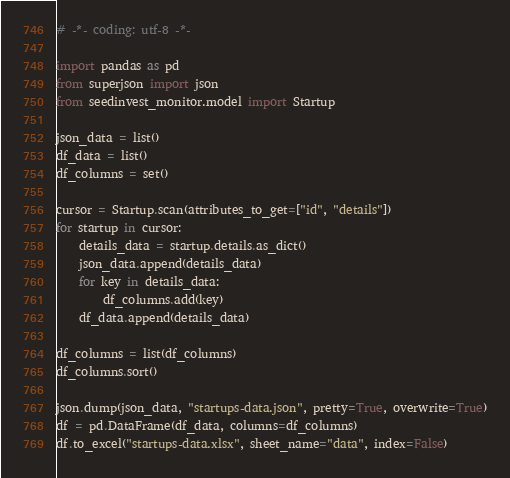Convert code to text. <code><loc_0><loc_0><loc_500><loc_500><_Python_># -*- coding: utf-8 -*-

import pandas as pd
from superjson import json
from seedinvest_monitor.model import Startup

json_data = list()
df_data = list()
df_columns = set()

cursor = Startup.scan(attributes_to_get=["id", "details"])
for startup in cursor:
    details_data = startup.details.as_dict()
    json_data.append(details_data)
    for key in details_data:
        df_columns.add(key)
    df_data.append(details_data)

df_columns = list(df_columns)
df_columns.sort()

json.dump(json_data, "startups-data.json", pretty=True, overwrite=True)
df = pd.DataFrame(df_data, columns=df_columns)
df.to_excel("startups-data.xlsx", sheet_name="data", index=False)
</code> 